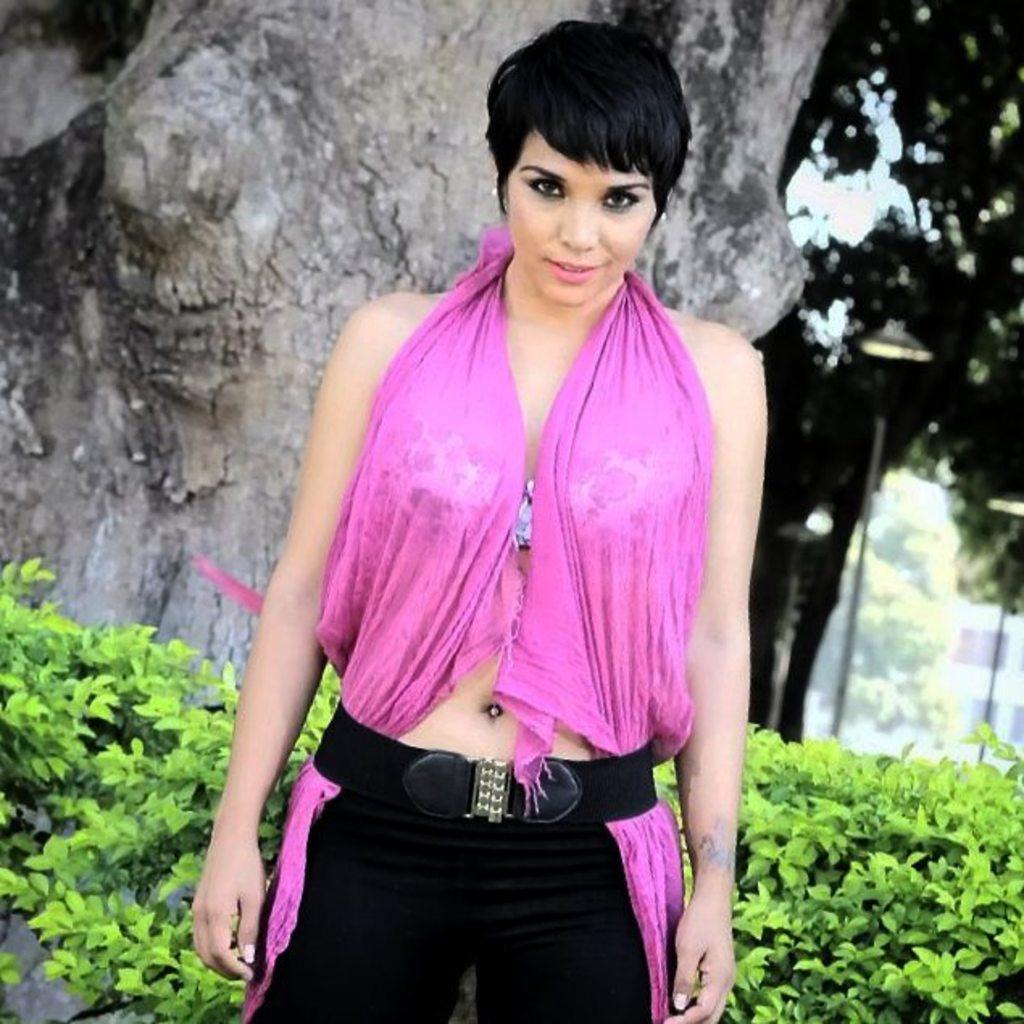How would you summarize this image in a sentence or two? This picture is clicked outside. In the center there is a woman wearing pink color dress and standing. In the background we can see the trunk of the tree and we can see the plants, trees and some other items. 